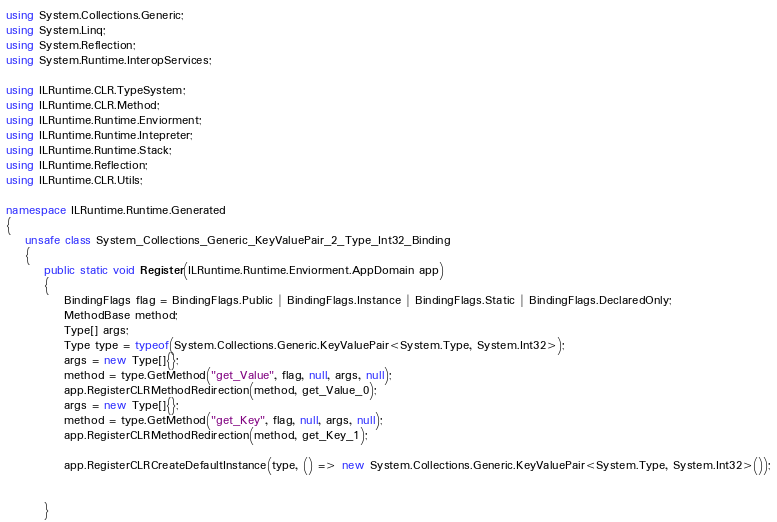Convert code to text. <code><loc_0><loc_0><loc_500><loc_500><_C#_>using System.Collections.Generic;
using System.Linq;
using System.Reflection;
using System.Runtime.InteropServices;

using ILRuntime.CLR.TypeSystem;
using ILRuntime.CLR.Method;
using ILRuntime.Runtime.Enviorment;
using ILRuntime.Runtime.Intepreter;
using ILRuntime.Runtime.Stack;
using ILRuntime.Reflection;
using ILRuntime.CLR.Utils;

namespace ILRuntime.Runtime.Generated
{
    unsafe class System_Collections_Generic_KeyValuePair_2_Type_Int32_Binding
    {
        public static void Register(ILRuntime.Runtime.Enviorment.AppDomain app)
        {
            BindingFlags flag = BindingFlags.Public | BindingFlags.Instance | BindingFlags.Static | BindingFlags.DeclaredOnly;
            MethodBase method;
            Type[] args;
            Type type = typeof(System.Collections.Generic.KeyValuePair<System.Type, System.Int32>);
            args = new Type[]{};
            method = type.GetMethod("get_Value", flag, null, args, null);
            app.RegisterCLRMethodRedirection(method, get_Value_0);
            args = new Type[]{};
            method = type.GetMethod("get_Key", flag, null, args, null);
            app.RegisterCLRMethodRedirection(method, get_Key_1);

            app.RegisterCLRCreateDefaultInstance(type, () => new System.Collections.Generic.KeyValuePair<System.Type, System.Int32>());


        }
</code> 